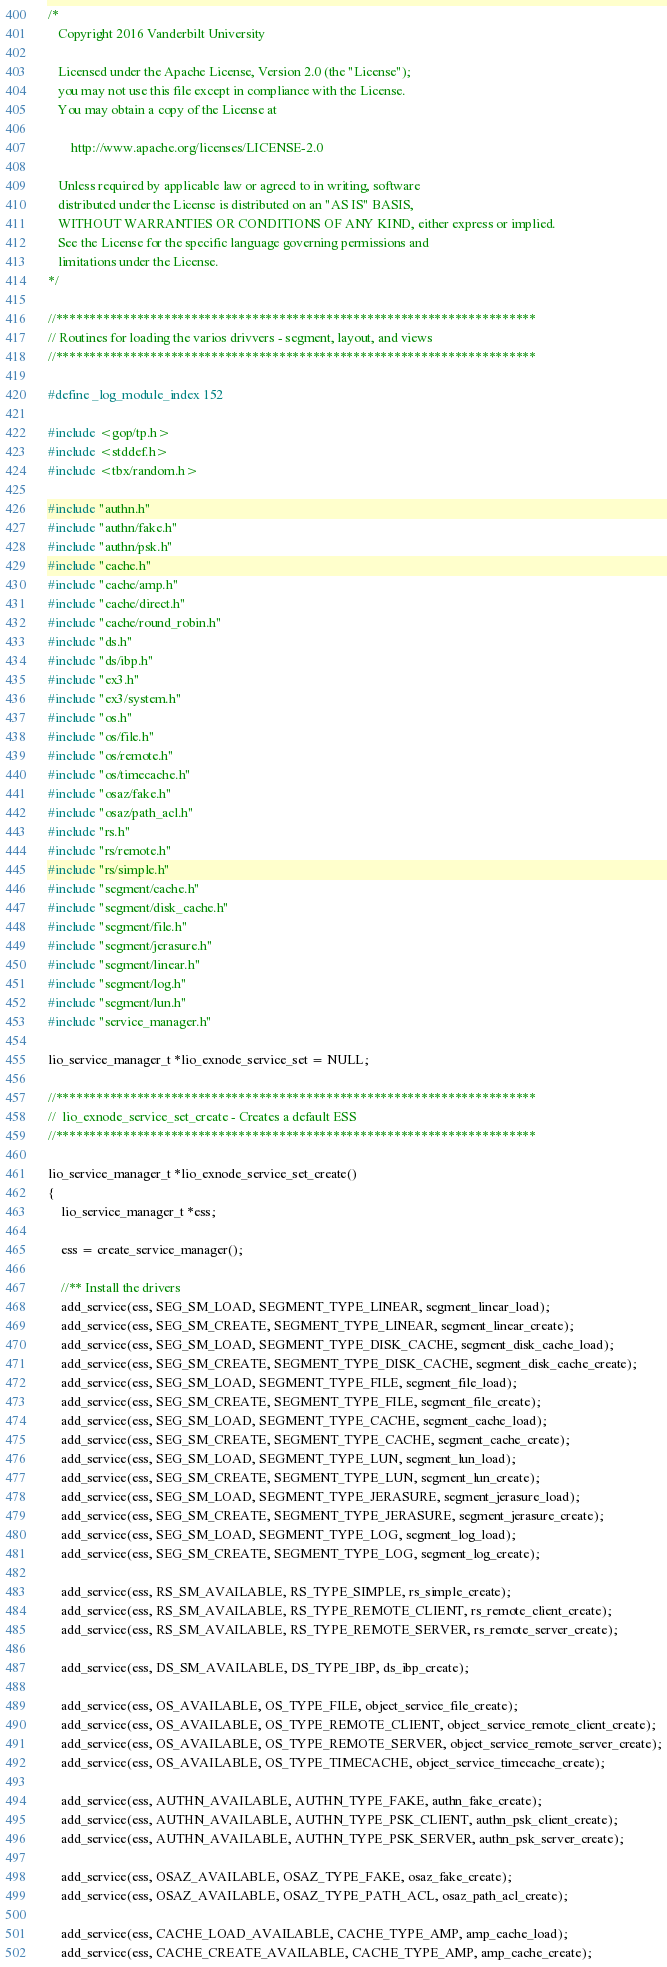<code> <loc_0><loc_0><loc_500><loc_500><_C_>/*
   Copyright 2016 Vanderbilt University

   Licensed under the Apache License, Version 2.0 (the "License");
   you may not use this file except in compliance with the License.
   You may obtain a copy of the License at

       http://www.apache.org/licenses/LICENSE-2.0

   Unless required by applicable law or agreed to in writing, software
   distributed under the License is distributed on an "AS IS" BASIS,
   WITHOUT WARRANTIES OR CONDITIONS OF ANY KIND, either express or implied.
   See the License for the specific language governing permissions and
   limitations under the License.
*/

//***********************************************************************
// Routines for loading the varios drivvers - segment, layout, and views
//***********************************************************************

#define _log_module_index 152

#include <gop/tp.h>
#include <stddef.h>
#include <tbx/random.h>

#include "authn.h"
#include "authn/fake.h"
#include "authn/psk.h"
#include "cache.h"
#include "cache/amp.h"
#include "cache/direct.h"
#include "cache/round_robin.h"
#include "ds.h"
#include "ds/ibp.h"
#include "ex3.h"
#include "ex3/system.h"
#include "os.h"
#include "os/file.h"
#include "os/remote.h"
#include "os/timecache.h"
#include "osaz/fake.h"
#include "osaz/path_acl.h"
#include "rs.h"
#include "rs/remote.h"
#include "rs/simple.h"
#include "segment/cache.h"
#include "segment/disk_cache.h"
#include "segment/file.h"
#include "segment/jerasure.h"
#include "segment/linear.h"
#include "segment/log.h"
#include "segment/lun.h"
#include "service_manager.h"

lio_service_manager_t *lio_exnode_service_set = NULL;

//***********************************************************************
//  lio_exnode_service_set_create - Creates a default ESS
//***********************************************************************

lio_service_manager_t *lio_exnode_service_set_create()
{
    lio_service_manager_t *ess;

    ess = create_service_manager();

    //** Install the drivers
    add_service(ess, SEG_SM_LOAD, SEGMENT_TYPE_LINEAR, segment_linear_load);
    add_service(ess, SEG_SM_CREATE, SEGMENT_TYPE_LINEAR, segment_linear_create);
    add_service(ess, SEG_SM_LOAD, SEGMENT_TYPE_DISK_CACHE, segment_disk_cache_load);
    add_service(ess, SEG_SM_CREATE, SEGMENT_TYPE_DISK_CACHE, segment_disk_cache_create);
    add_service(ess, SEG_SM_LOAD, SEGMENT_TYPE_FILE, segment_file_load);
    add_service(ess, SEG_SM_CREATE, SEGMENT_TYPE_FILE, segment_file_create);
    add_service(ess, SEG_SM_LOAD, SEGMENT_TYPE_CACHE, segment_cache_load);
    add_service(ess, SEG_SM_CREATE, SEGMENT_TYPE_CACHE, segment_cache_create);
    add_service(ess, SEG_SM_LOAD, SEGMENT_TYPE_LUN, segment_lun_load);
    add_service(ess, SEG_SM_CREATE, SEGMENT_TYPE_LUN, segment_lun_create);
    add_service(ess, SEG_SM_LOAD, SEGMENT_TYPE_JERASURE, segment_jerasure_load);
    add_service(ess, SEG_SM_CREATE, SEGMENT_TYPE_JERASURE, segment_jerasure_create);
    add_service(ess, SEG_SM_LOAD, SEGMENT_TYPE_LOG, segment_log_load);
    add_service(ess, SEG_SM_CREATE, SEGMENT_TYPE_LOG, segment_log_create);

    add_service(ess, RS_SM_AVAILABLE, RS_TYPE_SIMPLE, rs_simple_create);
    add_service(ess, RS_SM_AVAILABLE, RS_TYPE_REMOTE_CLIENT, rs_remote_client_create);
    add_service(ess, RS_SM_AVAILABLE, RS_TYPE_REMOTE_SERVER, rs_remote_server_create);

    add_service(ess, DS_SM_AVAILABLE, DS_TYPE_IBP, ds_ibp_create);

    add_service(ess, OS_AVAILABLE, OS_TYPE_FILE, object_service_file_create);
    add_service(ess, OS_AVAILABLE, OS_TYPE_REMOTE_CLIENT, object_service_remote_client_create);
    add_service(ess, OS_AVAILABLE, OS_TYPE_REMOTE_SERVER, object_service_remote_server_create);
    add_service(ess, OS_AVAILABLE, OS_TYPE_TIMECACHE, object_service_timecache_create);

    add_service(ess, AUTHN_AVAILABLE, AUTHN_TYPE_FAKE, authn_fake_create);
    add_service(ess, AUTHN_AVAILABLE, AUTHN_TYPE_PSK_CLIENT, authn_psk_client_create);
    add_service(ess, AUTHN_AVAILABLE, AUTHN_TYPE_PSK_SERVER, authn_psk_server_create);

    add_service(ess, OSAZ_AVAILABLE, OSAZ_TYPE_FAKE, osaz_fake_create);
    add_service(ess, OSAZ_AVAILABLE, OSAZ_TYPE_PATH_ACL, osaz_path_acl_create);

    add_service(ess, CACHE_LOAD_AVAILABLE, CACHE_TYPE_AMP, amp_cache_load);
    add_service(ess, CACHE_CREATE_AVAILABLE, CACHE_TYPE_AMP, amp_cache_create);</code> 